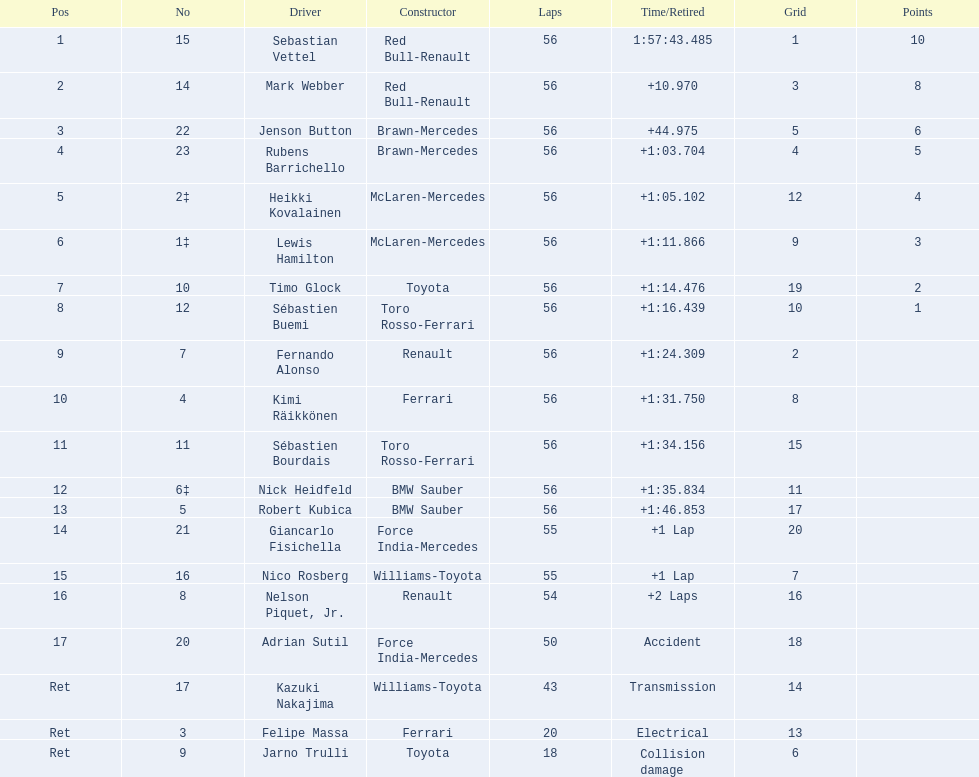Who are all of the drivers? Sebastian Vettel, Mark Webber, Jenson Button, Rubens Barrichello, Heikki Kovalainen, Lewis Hamilton, Timo Glock, Sébastien Buemi, Fernando Alonso, Kimi Räikkönen, Sébastien Bourdais, Nick Heidfeld, Robert Kubica, Giancarlo Fisichella, Nico Rosberg, Nelson Piquet, Jr., Adrian Sutil, Kazuki Nakajima, Felipe Massa, Jarno Trulli. Could you parse the entire table as a dict? {'header': ['Pos', 'No', 'Driver', 'Constructor', 'Laps', 'Time/Retired', 'Grid', 'Points'], 'rows': [['1', '15', 'Sebastian Vettel', 'Red Bull-Renault', '56', '1:57:43.485', '1', '10'], ['2', '14', 'Mark Webber', 'Red Bull-Renault', '56', '+10.970', '3', '8'], ['3', '22', 'Jenson Button', 'Brawn-Mercedes', '56', '+44.975', '5', '6'], ['4', '23', 'Rubens Barrichello', 'Brawn-Mercedes', '56', '+1:03.704', '4', '5'], ['5', '2‡', 'Heikki Kovalainen', 'McLaren-Mercedes', '56', '+1:05.102', '12', '4'], ['6', '1‡', 'Lewis Hamilton', 'McLaren-Mercedes', '56', '+1:11.866', '9', '3'], ['7', '10', 'Timo Glock', 'Toyota', '56', '+1:14.476', '19', '2'], ['8', '12', 'Sébastien Buemi', 'Toro Rosso-Ferrari', '56', '+1:16.439', '10', '1'], ['9', '7', 'Fernando Alonso', 'Renault', '56', '+1:24.309', '2', ''], ['10', '4', 'Kimi Räikkönen', 'Ferrari', '56', '+1:31.750', '8', ''], ['11', '11', 'Sébastien Bourdais', 'Toro Rosso-Ferrari', '56', '+1:34.156', '15', ''], ['12', '6‡', 'Nick Heidfeld', 'BMW Sauber', '56', '+1:35.834', '11', ''], ['13', '5', 'Robert Kubica', 'BMW Sauber', '56', '+1:46.853', '17', ''], ['14', '21', 'Giancarlo Fisichella', 'Force India-Mercedes', '55', '+1 Lap', '20', ''], ['15', '16', 'Nico Rosberg', 'Williams-Toyota', '55', '+1 Lap', '7', ''], ['16', '8', 'Nelson Piquet, Jr.', 'Renault', '54', '+2 Laps', '16', ''], ['17', '20', 'Adrian Sutil', 'Force India-Mercedes', '50', 'Accident', '18', ''], ['Ret', '17', 'Kazuki Nakajima', 'Williams-Toyota', '43', 'Transmission', '14', ''], ['Ret', '3', 'Felipe Massa', 'Ferrari', '20', 'Electrical', '13', ''], ['Ret', '9', 'Jarno Trulli', 'Toyota', '18', 'Collision damage', '6', '']]} Who were their constructors? Red Bull-Renault, Red Bull-Renault, Brawn-Mercedes, Brawn-Mercedes, McLaren-Mercedes, McLaren-Mercedes, Toyota, Toro Rosso-Ferrari, Renault, Ferrari, Toro Rosso-Ferrari, BMW Sauber, BMW Sauber, Force India-Mercedes, Williams-Toyota, Renault, Force India-Mercedes, Williams-Toyota, Ferrari, Toyota. Who was the first listed driver to not drive a ferrari?? Sebastian Vettel. 